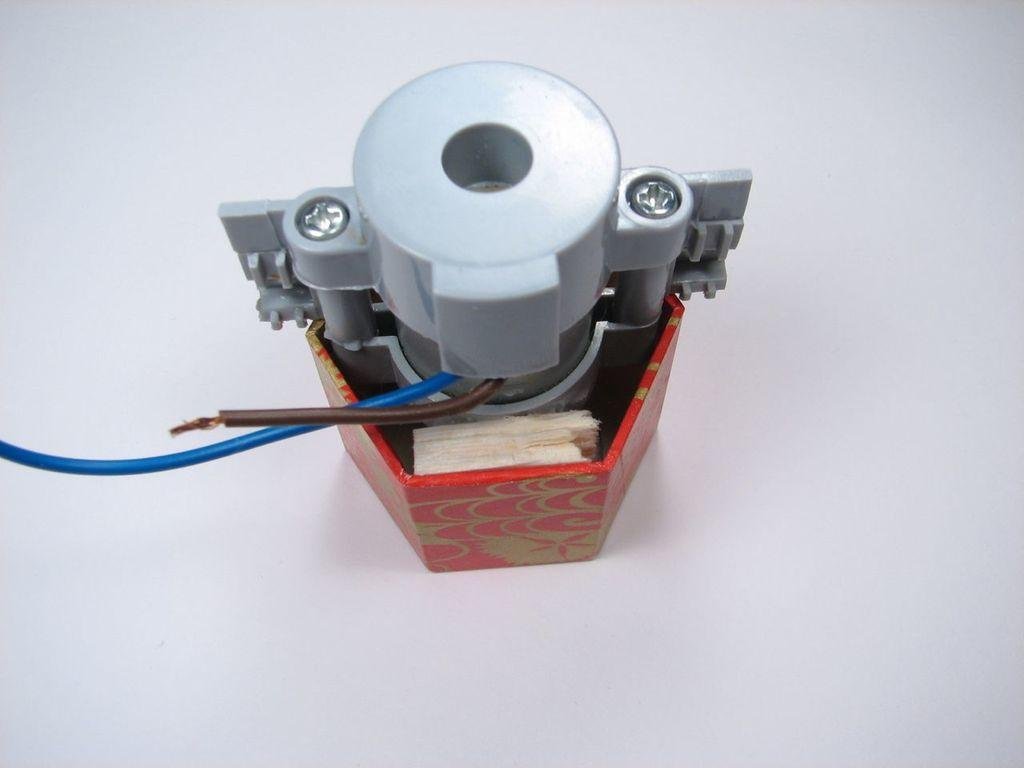What is the main subject of the image? There is an object in the image. How are the wires connected to the object? Two wires are attached to the object. What color is the background of the image? The background of the image is white. What type of cent is visible in the image? There is no cent present in the image. Can you tell me the ruling of the judge in the image? There is no judge present in the image. 